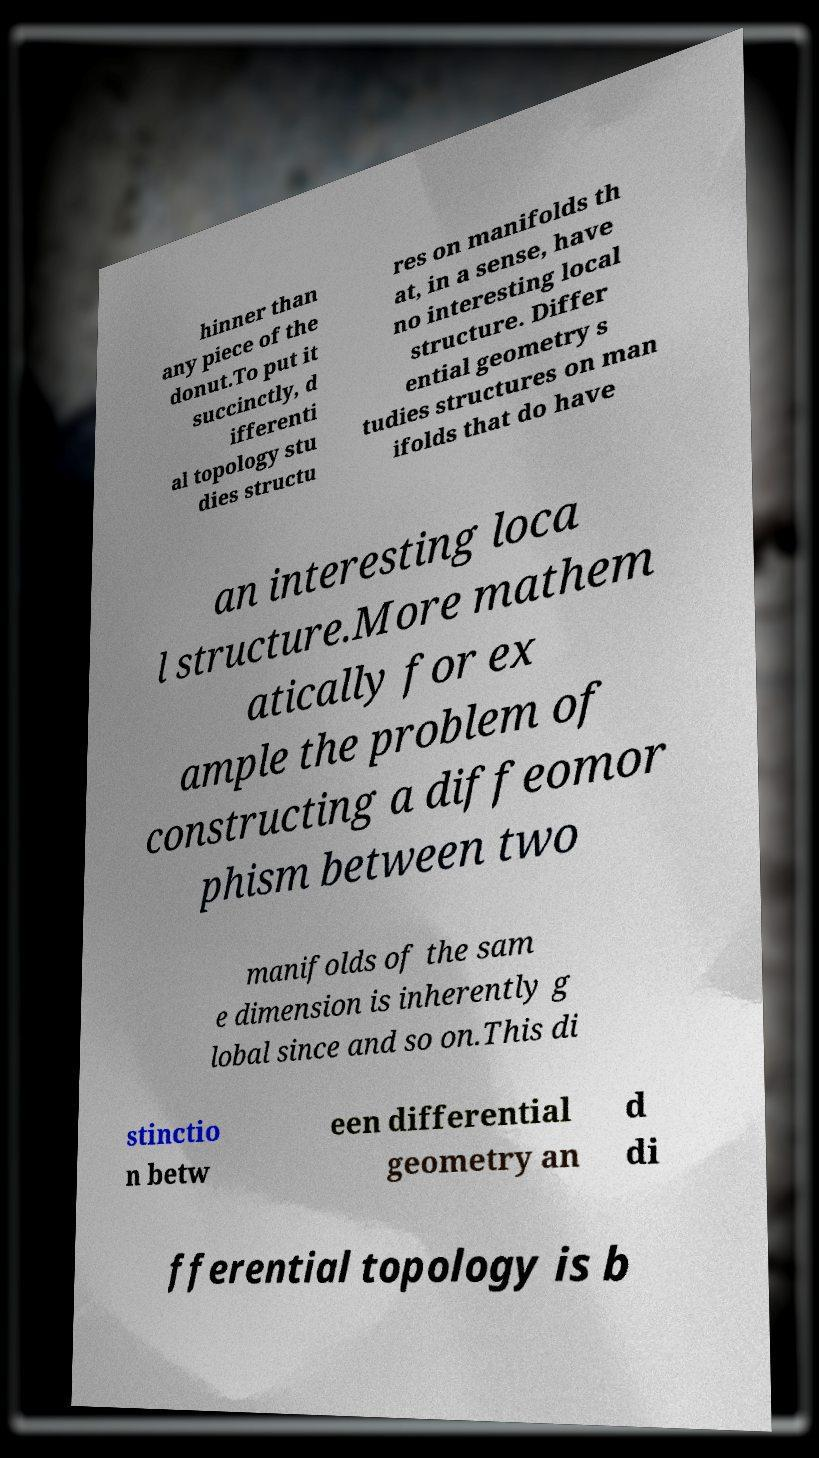For documentation purposes, I need the text within this image transcribed. Could you provide that? hinner than any piece of the donut.To put it succinctly, d ifferenti al topology stu dies structu res on manifolds th at, in a sense, have no interesting local structure. Differ ential geometry s tudies structures on man ifolds that do have an interesting loca l structure.More mathem atically for ex ample the problem of constructing a diffeomor phism between two manifolds of the sam e dimension is inherently g lobal since and so on.This di stinctio n betw een differential geometry an d di fferential topology is b 